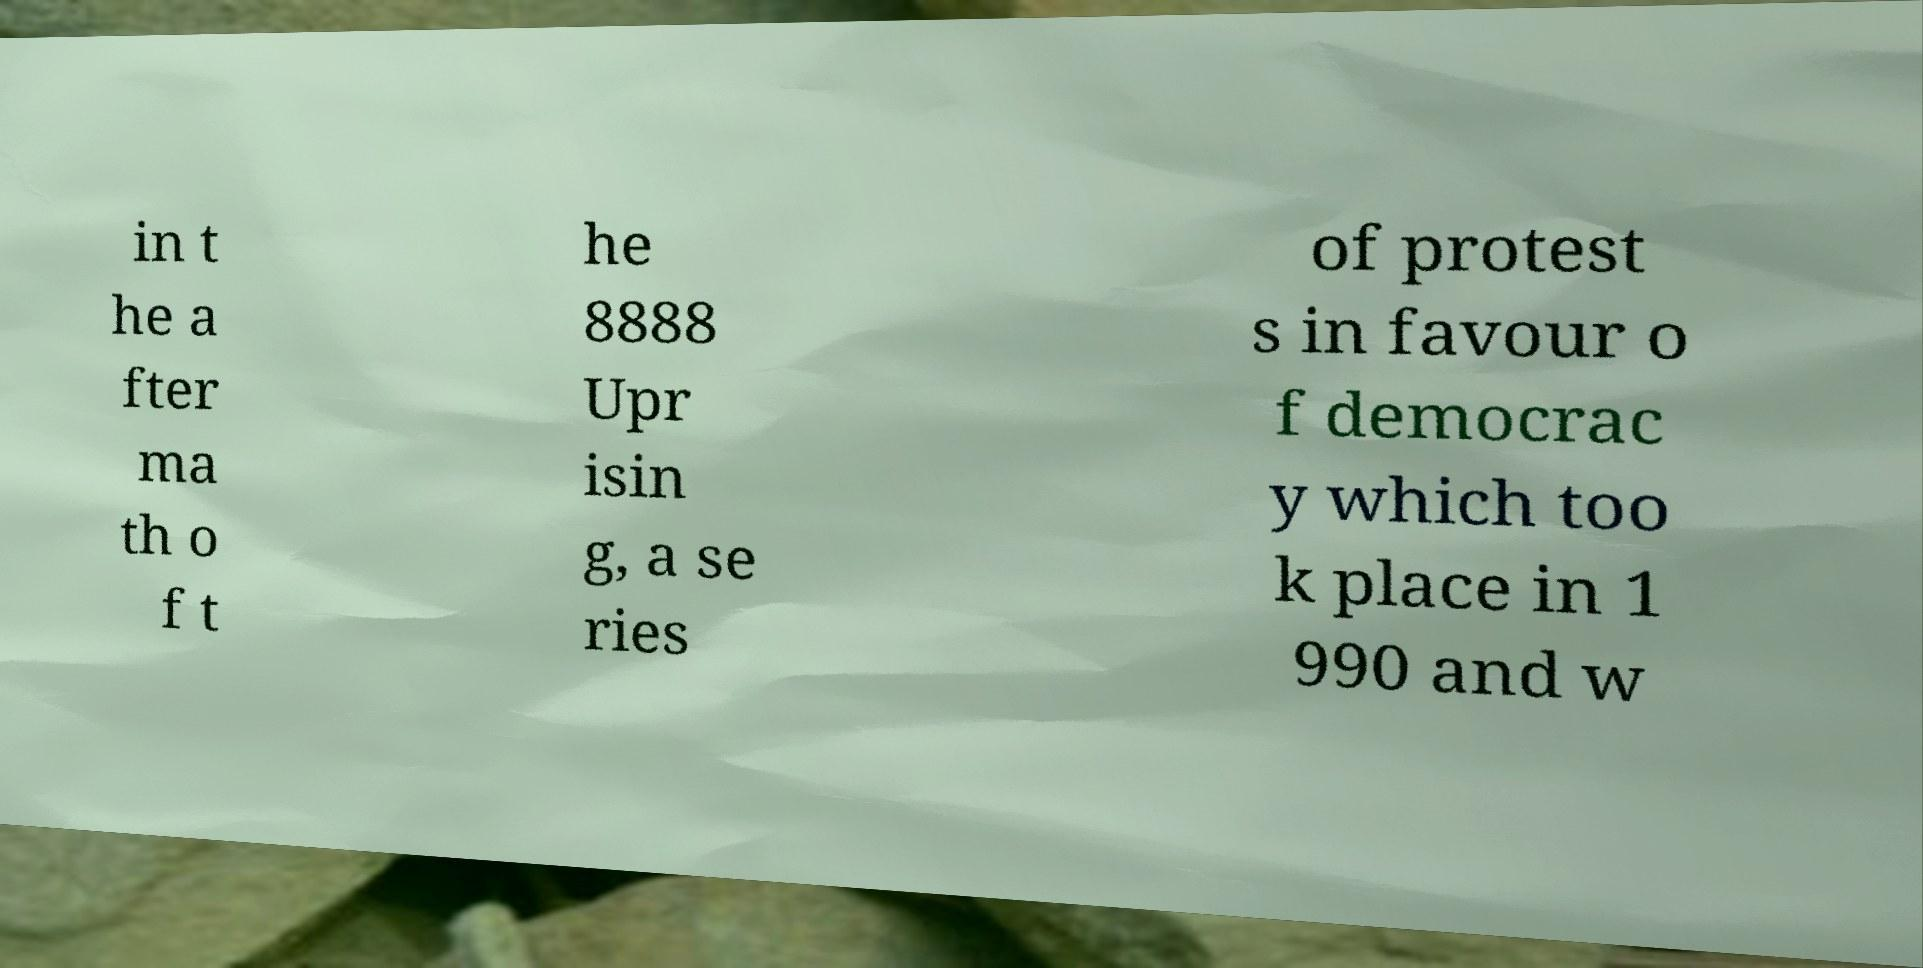Can you accurately transcribe the text from the provided image for me? in t he a fter ma th o f t he 8888 Upr isin g, a se ries of protest s in favour o f democrac y which too k place in 1 990 and w 